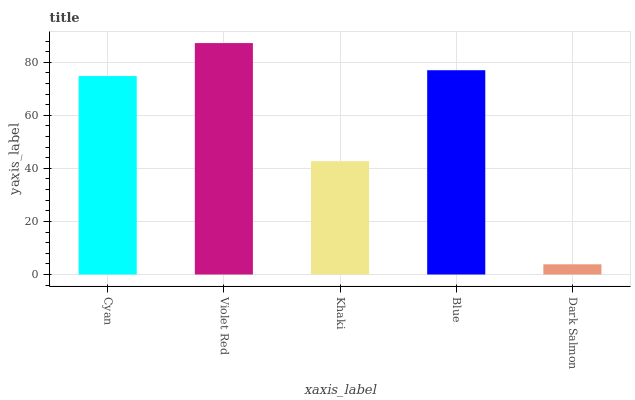Is Dark Salmon the minimum?
Answer yes or no. Yes. Is Violet Red the maximum?
Answer yes or no. Yes. Is Khaki the minimum?
Answer yes or no. No. Is Khaki the maximum?
Answer yes or no. No. Is Violet Red greater than Khaki?
Answer yes or no. Yes. Is Khaki less than Violet Red?
Answer yes or no. Yes. Is Khaki greater than Violet Red?
Answer yes or no. No. Is Violet Red less than Khaki?
Answer yes or no. No. Is Cyan the high median?
Answer yes or no. Yes. Is Cyan the low median?
Answer yes or no. Yes. Is Khaki the high median?
Answer yes or no. No. Is Dark Salmon the low median?
Answer yes or no. No. 